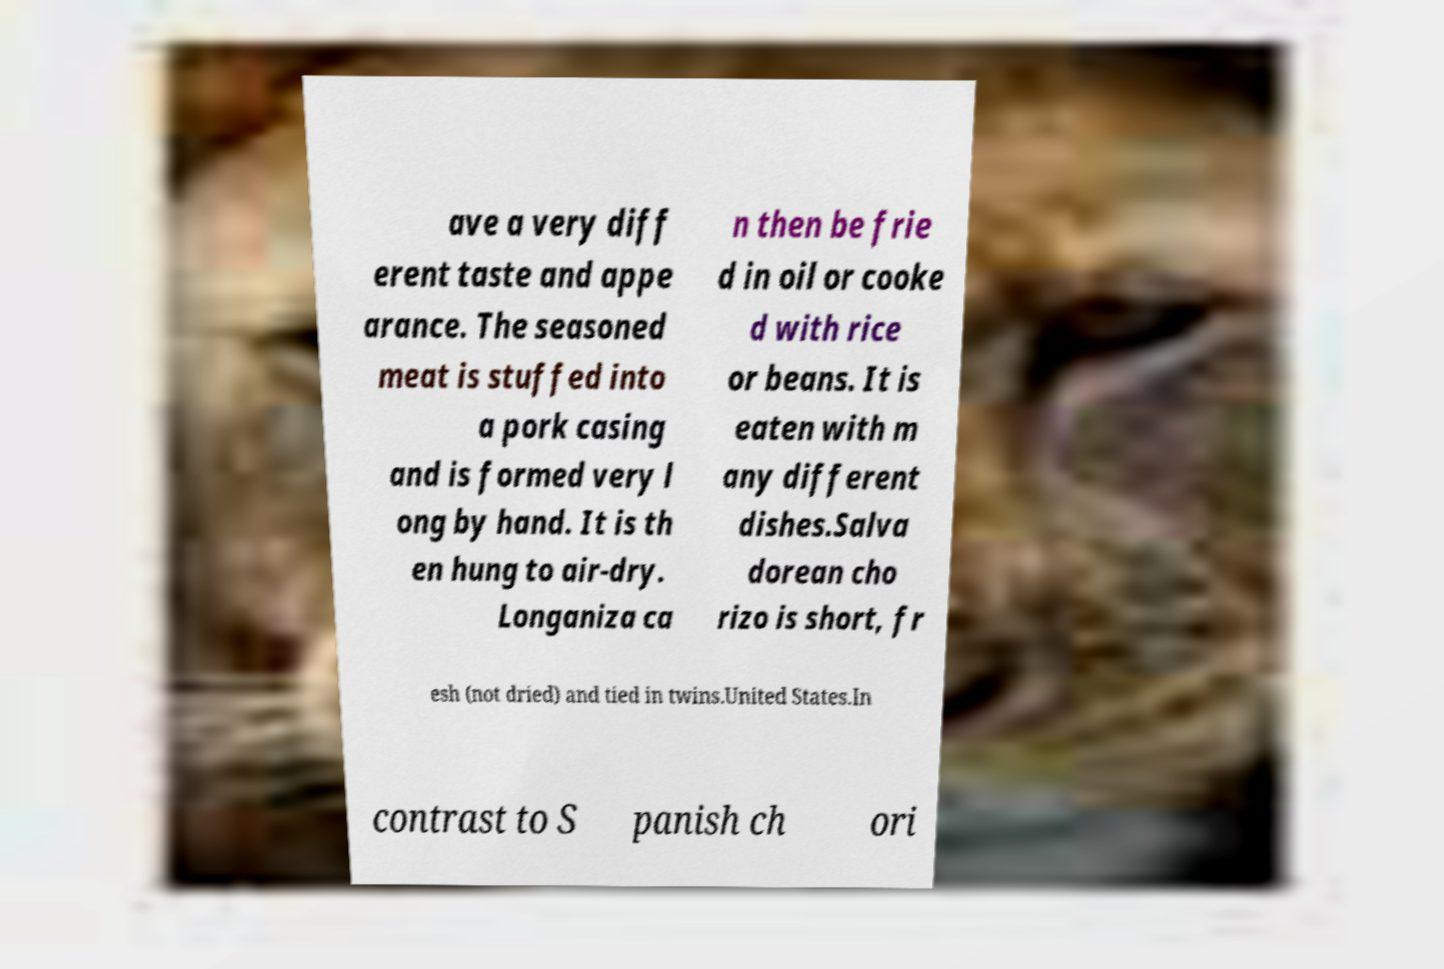Can you read and provide the text displayed in the image?This photo seems to have some interesting text. Can you extract and type it out for me? ave a very diff erent taste and appe arance. The seasoned meat is stuffed into a pork casing and is formed very l ong by hand. It is th en hung to air-dry. Longaniza ca n then be frie d in oil or cooke d with rice or beans. It is eaten with m any different dishes.Salva dorean cho rizo is short, fr esh (not dried) and tied in twins.United States.In contrast to S panish ch ori 